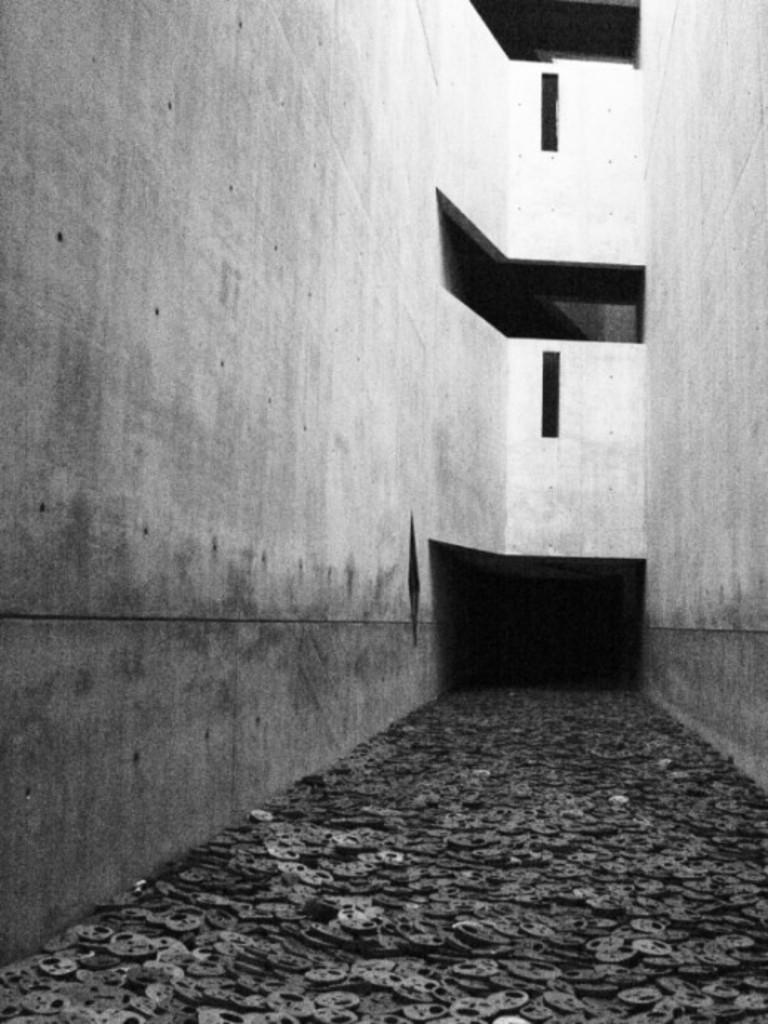What is on the floor in the image? There are objects on the floor in the image. What can be seen in the background of the image? There is a wall in the background of the image. How does the sneeze affect the objects on the floor in the image? There is no sneeze present in the image, so it cannot affect the objects on the floor. What type of verse is written on the wall in the image? There is no verse written on the wall in the image; only a wall is visible in the background. 